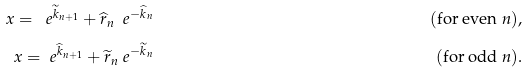<formula> <loc_0><loc_0><loc_500><loc_500>x = \ e ^ { \widetilde { k } _ { n + 1 } } + \widehat { r } _ { n } \ e ^ { - \widehat { k } _ { n } } & & ( \text {for even $n$} ) , \\ x = \ e ^ { \widehat { k } _ { n + 1 } } + \widetilde { r } _ { n } \ e ^ { - \widetilde { k } _ { n } } & & ( \text {for odd $n$} ) .</formula> 